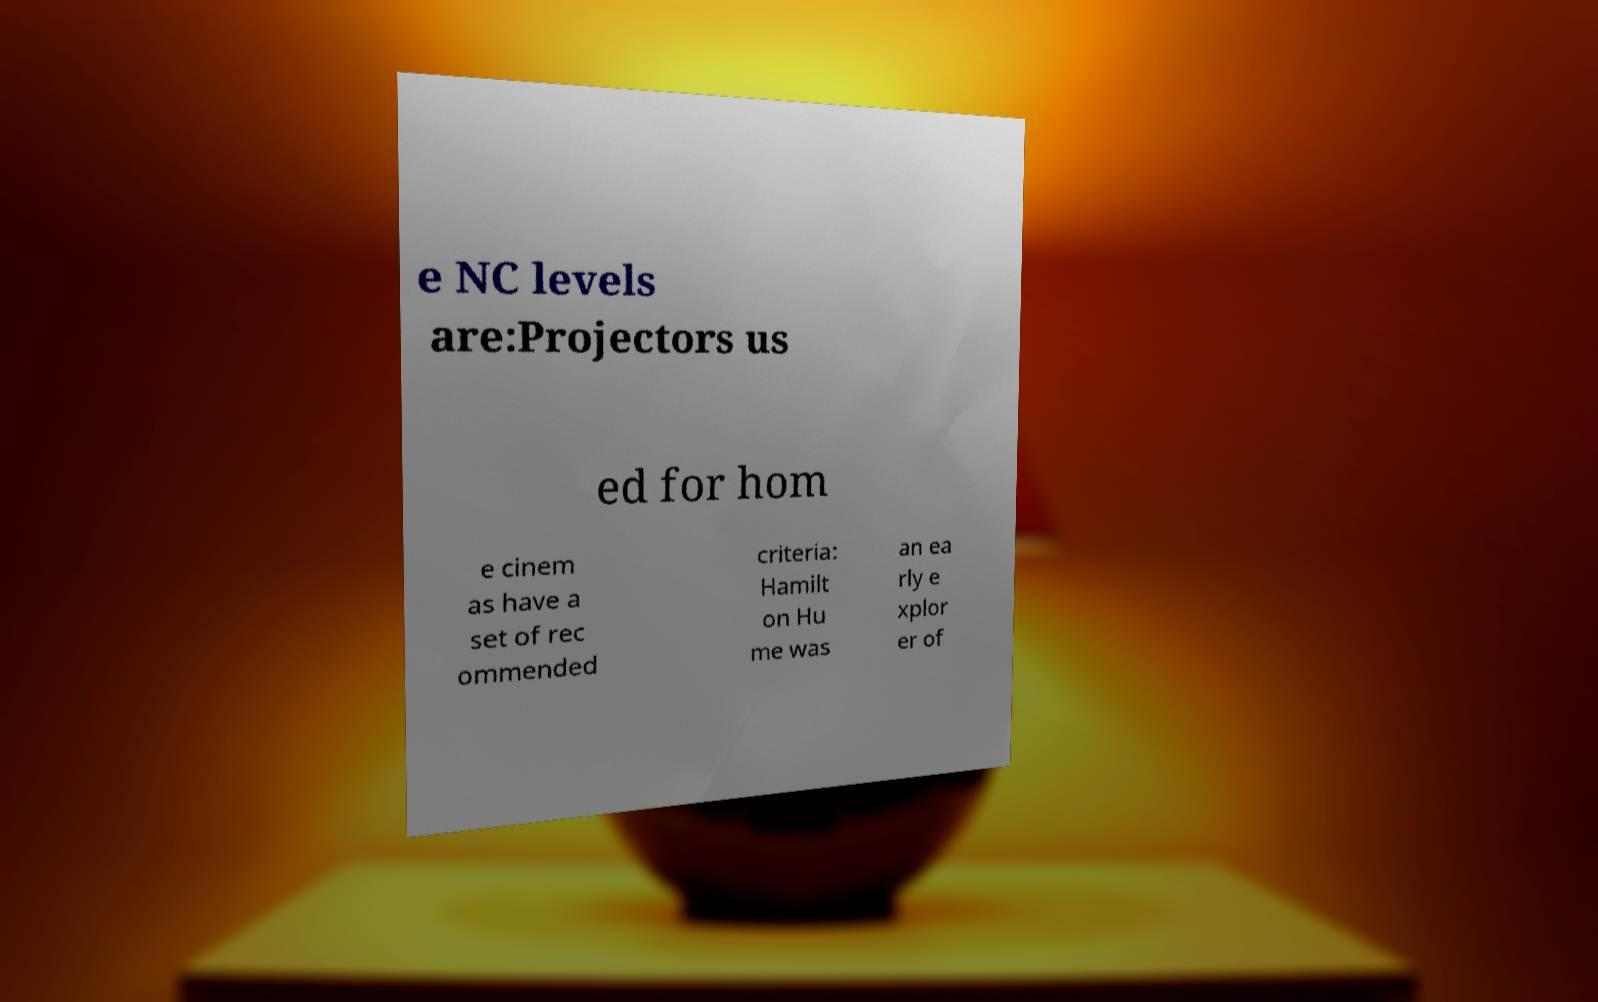Can you read and provide the text displayed in the image?This photo seems to have some interesting text. Can you extract and type it out for me? e NC levels are:Projectors us ed for hom e cinem as have a set of rec ommended criteria: Hamilt on Hu me was an ea rly e xplor er of 